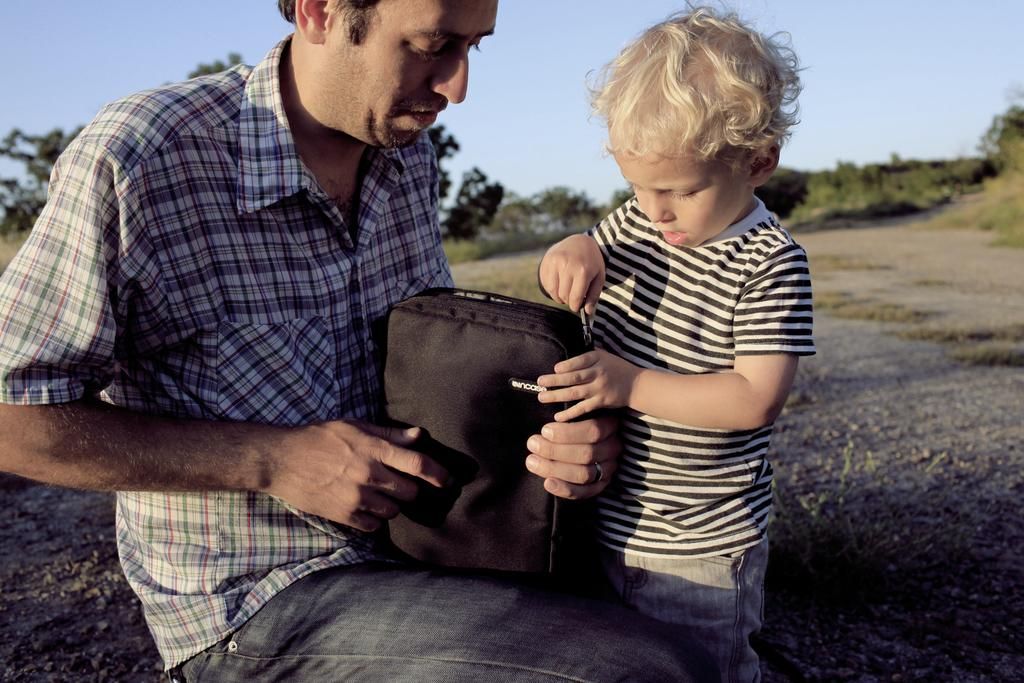What is the man in the image doing? There is a man sitting in the image. Who else is present in the image? There is a kid in the image. What is the kid holding? The kid is holding a black bag zip. What can be seen in the background of the image? There are trees in the background of the image. What is visible above the trees? The sky is visible in the image. What type of produce is being transported in the quiver in the image? There is no quiver or produce present in the image. 